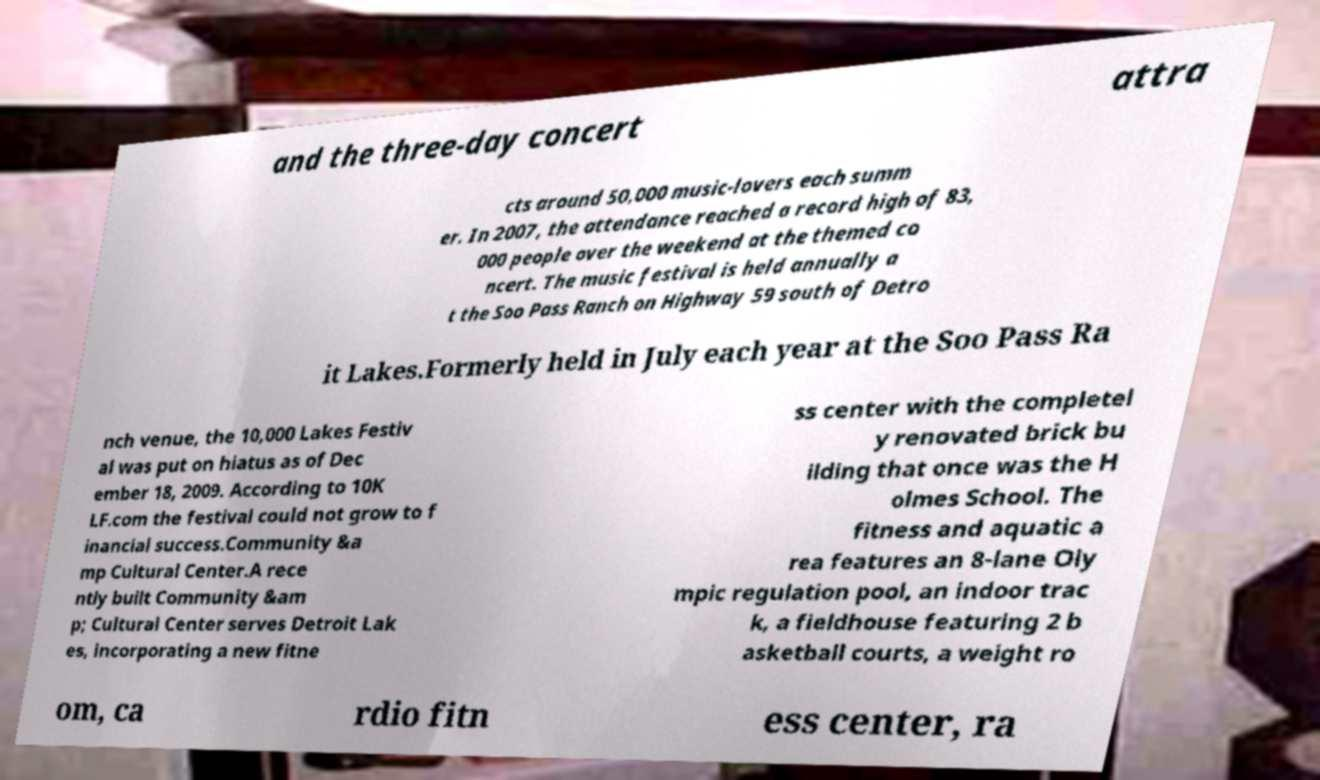Please identify and transcribe the text found in this image. and the three-day concert attra cts around 50,000 music-lovers each summ er. In 2007, the attendance reached a record high of 83, 000 people over the weekend at the themed co ncert. The music festival is held annually a t the Soo Pass Ranch on Highway 59 south of Detro it Lakes.Formerly held in July each year at the Soo Pass Ra nch venue, the 10,000 Lakes Festiv al was put on hiatus as of Dec ember 18, 2009. According to 10K LF.com the festival could not grow to f inancial success.Community &a mp Cultural Center.A rece ntly built Community &am p; Cultural Center serves Detroit Lak es, incorporating a new fitne ss center with the completel y renovated brick bu ilding that once was the H olmes School. The fitness and aquatic a rea features an 8-lane Oly mpic regulation pool, an indoor trac k, a fieldhouse featuring 2 b asketball courts, a weight ro om, ca rdio fitn ess center, ra 